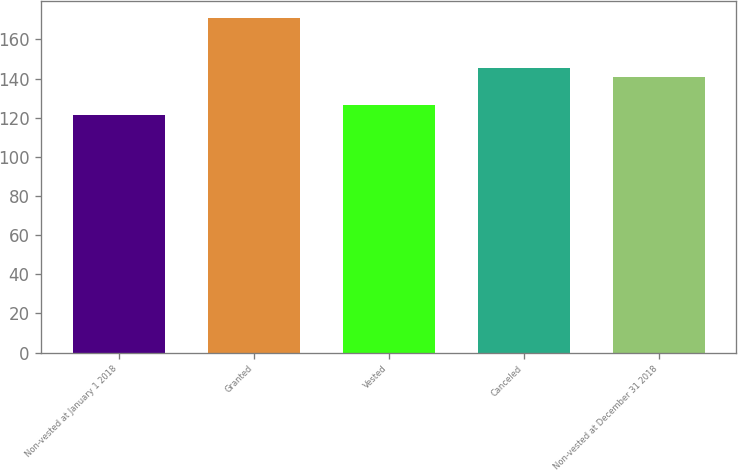Convert chart to OTSL. <chart><loc_0><loc_0><loc_500><loc_500><bar_chart><fcel>Non-vested at January 1 2018<fcel>Granted<fcel>Vested<fcel>Canceled<fcel>Non-vested at December 31 2018<nl><fcel>121.36<fcel>170.93<fcel>126.32<fcel>145.54<fcel>140.58<nl></chart> 